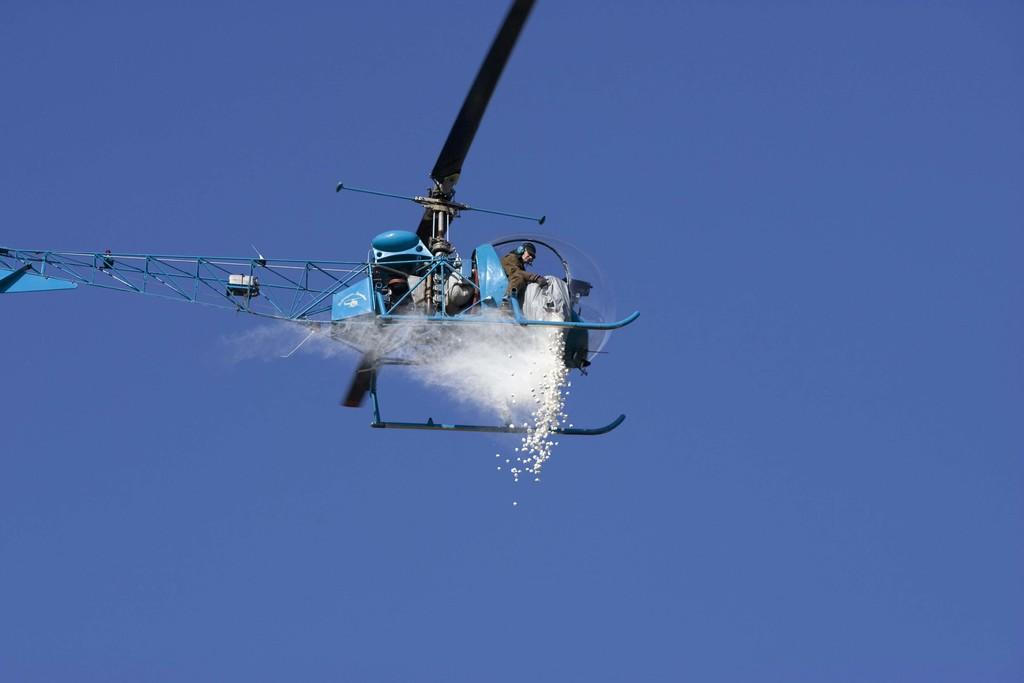Who is present in the image? There is a man in the image. What is the man holding in the image? The man is holding a bag. What action is the man performing in the image? The man is leaving something into the air. How would you describe the weather in the image? The sky is cloudy in the image. How many dogs are visible in the image? There are no dogs present in the image. What type of line is being drawn in the image? There is no line being drawn in the image. 